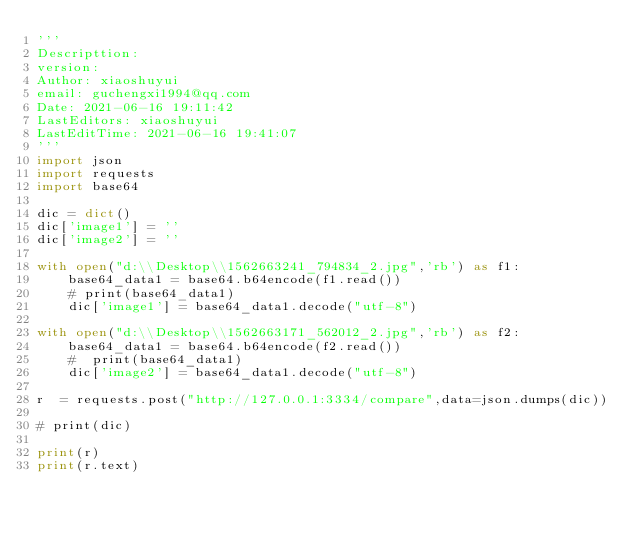Convert code to text. <code><loc_0><loc_0><loc_500><loc_500><_Python_>'''
Descripttion: 
version: 
Author: xiaoshuyui
email: guchengxi1994@qq.com
Date: 2021-06-16 19:11:42
LastEditors: xiaoshuyui
LastEditTime: 2021-06-16 19:41:07
'''
import json
import requests
import base64

dic = dict()
dic['image1'] = ''
dic['image2'] = ''

with open("d:\\Desktop\\1562663241_794834_2.jpg",'rb') as f1:
    base64_data1 = base64.b64encode(f1.read())
    # print(base64_data1)
    dic['image1'] = base64_data1.decode("utf-8")

with open("d:\\Desktop\\1562663171_562012_2.jpg",'rb') as f2:
    base64_data1 = base64.b64encode(f2.read())
    #  print(base64_data1)
    dic['image2'] = base64_data1.decode("utf-8")

r  = requests.post("http://127.0.0.1:3334/compare",data=json.dumps(dic))

# print(dic)

print(r)
print(r.text)</code> 